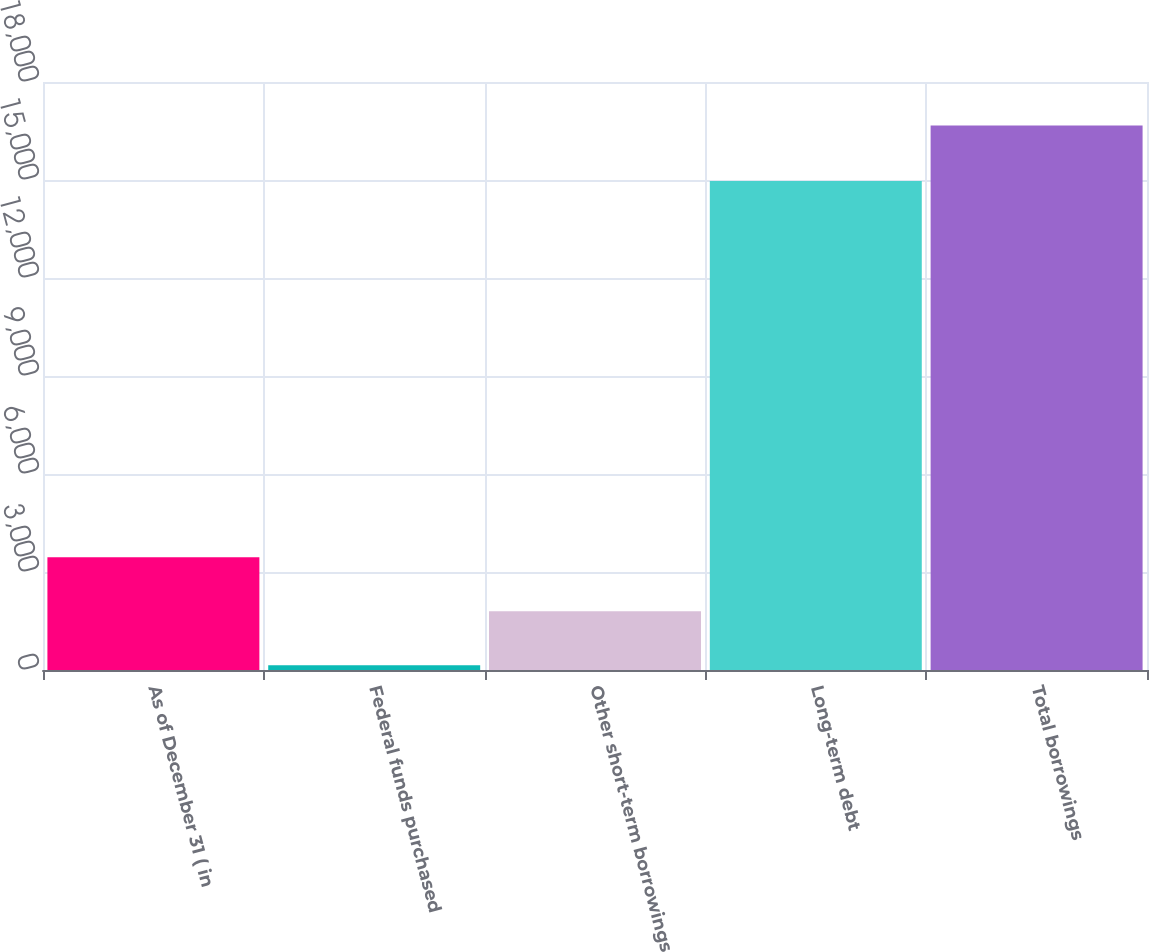Convert chart. <chart><loc_0><loc_0><loc_500><loc_500><bar_chart><fcel>As of December 31 ( in<fcel>Federal funds purchased<fcel>Other short-term borrowings<fcel>Long-term debt<fcel>Total borrowings<nl><fcel>3448.6<fcel>144<fcel>1796.3<fcel>14967<fcel>16667<nl></chart> 